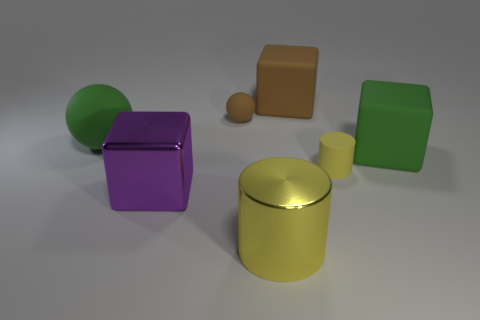Can you describe the shapes and colors you see in the picture? Certainly! There are various geometric shapes present in the image, each with a distinct color. I can observe a large green sphere, a purple cube, a yellow cylinder, an orange cuboid, and a small brown sphere. Additionally, there's a matte green cube and a matte green rectangular prism. 